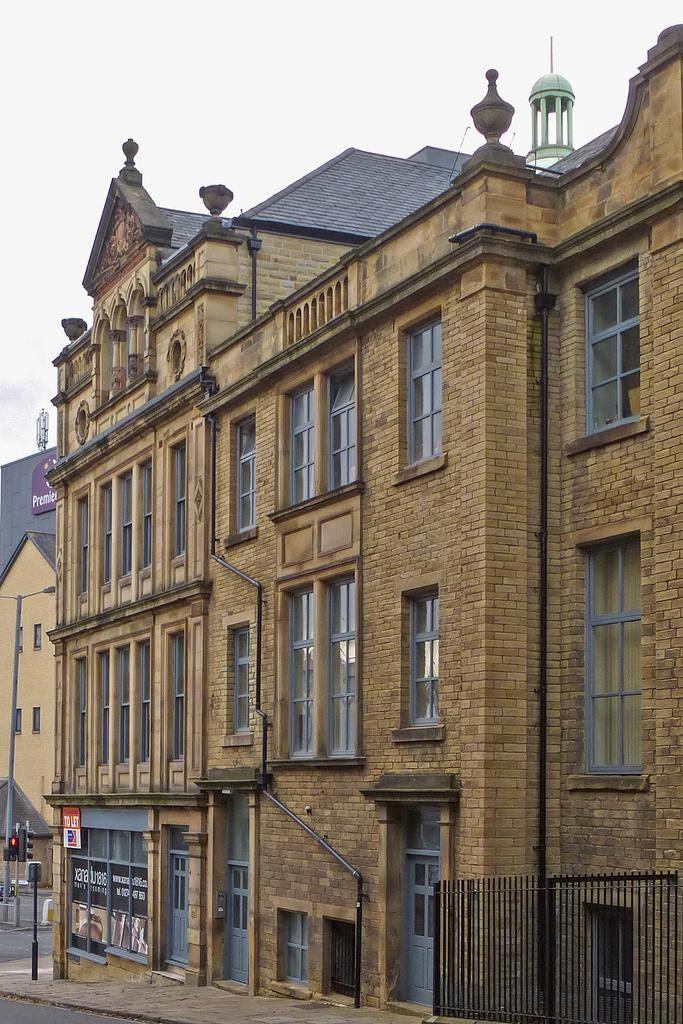What type of structure can be seen in the image? There is a brick building in the image. What is attached to a pole in the image? There is a board attached to a pole in the image. What type of poles are present in the image? There are traffic signal poles and light poles in the image. What is visible in the background of the image? The sky is visible in the background of the image. What type of vegetable is being distributed at the border in the image? There is no vegetable or distribution activity present in the image. 